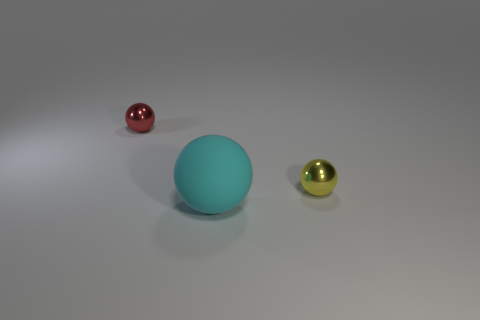Add 3 big rubber balls. How many objects exist? 6 Subtract 1 cyan balls. How many objects are left? 2 Subtract all small red shiny spheres. Subtract all cyan rubber balls. How many objects are left? 1 Add 1 cyan matte things. How many cyan matte things are left? 2 Add 2 small yellow cylinders. How many small yellow cylinders exist? 2 